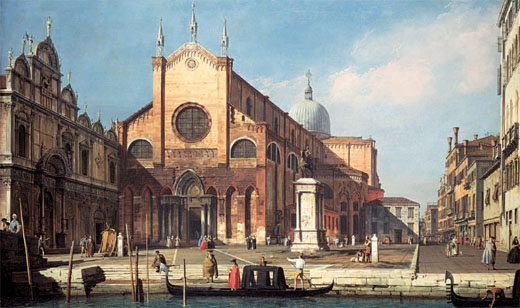Imagine an alternate reality where this church is a portal to another world. How would the scene change? In an alternate reality where this church serves as a portal to another world, the scene would shift drastically. The square would be filled with curious adventurers, each eager to glimpse the wonders beyond the portal. The serene waters of the canal might ripple with the energy of unknown realms, revealing glimpses of fantastical creatures swimming beneath. The church itself would glow with otherworldly light, casting ethereal hues on the stone facades around it. Merchants might sell exotic artifacts and interdimensional wares, while musicians play instruments that emit celestial sounds. This transformed cityscape would blur the lines between Venice and the alternate reality, creating a magical convergence of worlds. 